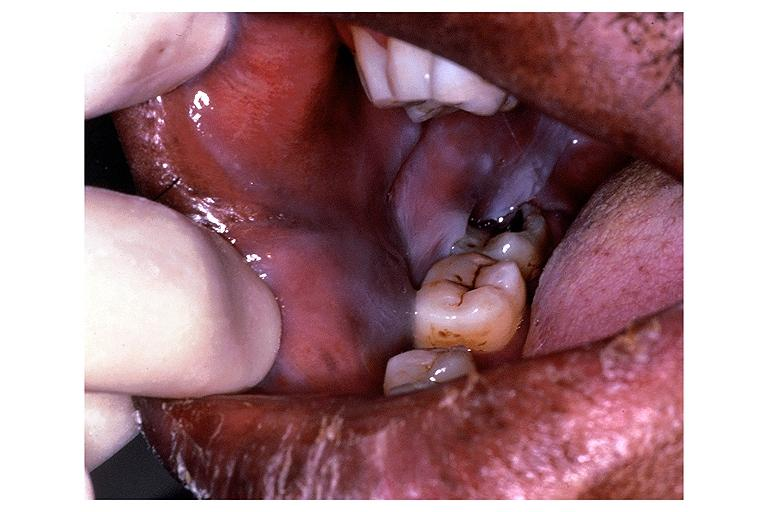where is this?
Answer the question using a single word or phrase. Oral 